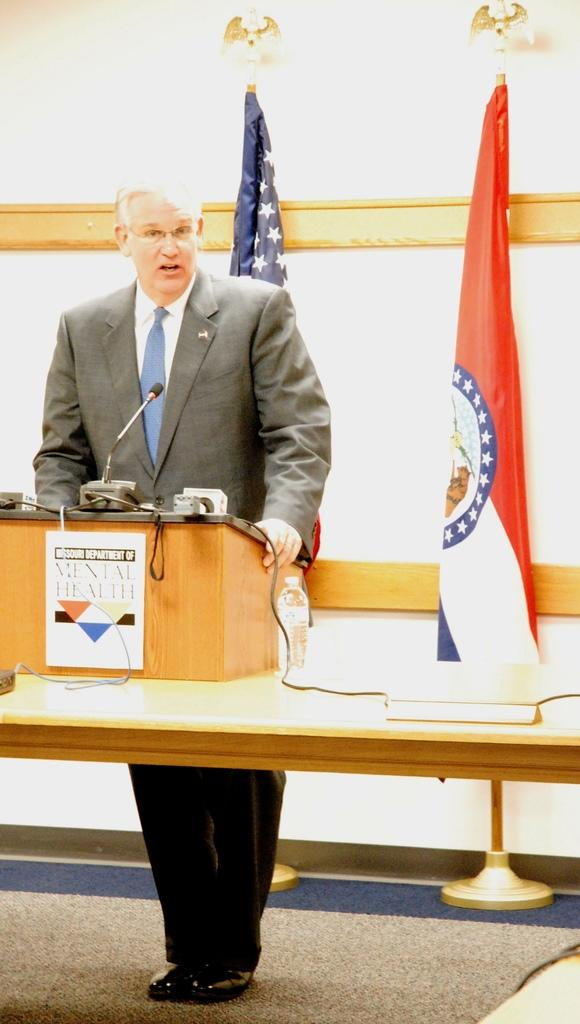What is the man doing in the image? There is a man standing in the image. What object is present near the man? There is a podium in the image. What is on the podium? A microphone is present on the podium. What can be seen in the background of the image? There is a flag visible in the image. What type of key is the man holding in the image? There is no key present in the image; the man is not holding anything. 